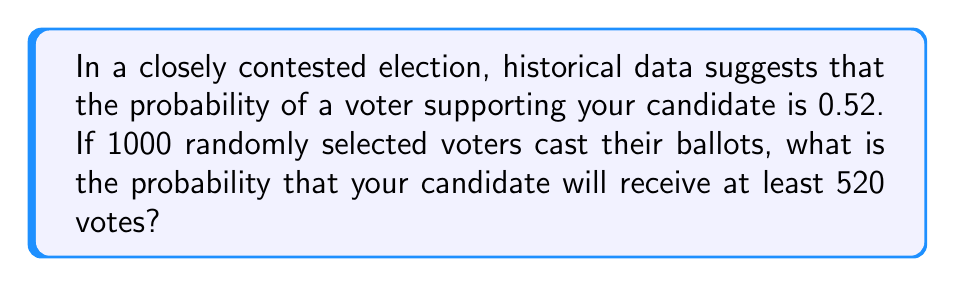Give your solution to this math problem. To solve this problem, we can use the binomial distribution, which is appropriate for situations with a fixed number of independent trials (voters) and two possible outcomes (support or not support).

Let $X$ be the number of voters supporting your candidate.

$X \sim B(n,p)$ where:
$n = 1000$ (number of voters)
$p = 0.52$ (probability of supporting your candidate)

We want to find $P(X \geq 520)$

For large $n$, we can approximate the binomial distribution with a normal distribution:

$X \sim N(\mu, \sigma^2)$ where:
$\mu = np = 1000 \cdot 0.52 = 520$
$\sigma^2 = np(1-p) = 1000 \cdot 0.52 \cdot 0.48 = 249.6$
$\sigma = \sqrt{249.6} \approx 15.8$

Now, we need to find:

$$P(X \geq 520) = 1 - P(X < 520)$$

Using the continuity correction:

$$P(X \geq 520) = 1 - P(X < 519.5)$$

Standardizing:

$$Z = \frac{519.5 - 520}{15.8} = -0.0316$$

Using a standard normal distribution table or calculator:

$$P(Z < -0.0316) = 0.4874$$

Therefore:

$$P(X \geq 520) = 1 - 0.4874 = 0.5126$$
Answer: The probability that your candidate will receive at least 520 votes is approximately 0.5126 or 51.26%. 